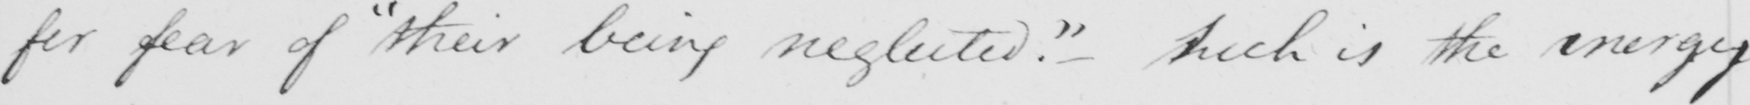Transcribe the text shown in this historical manuscript line. for fear of  " their being neglected . "  - Such is the energy 